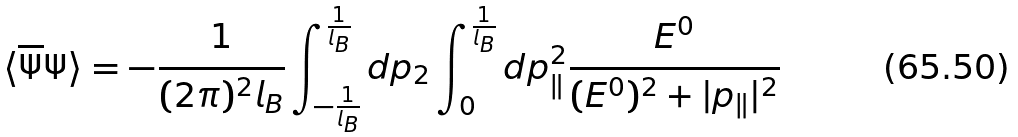<formula> <loc_0><loc_0><loc_500><loc_500>\langle \overline { \Psi } \Psi \rangle = - \frac { 1 } { ( 2 \pi ) ^ { 2 } l _ { B } } \int _ { - \frac { 1 } { l _ { B } } } ^ { \frac { 1 } { l _ { B } } } d p _ { 2 } \int _ { 0 } ^ { \frac { 1 } { l _ { B } } } d p _ { \| } ^ { 2 } \frac { E ^ { 0 } } { ( E ^ { 0 } ) ^ { 2 } + | p _ { \| } | ^ { 2 } }</formula> 